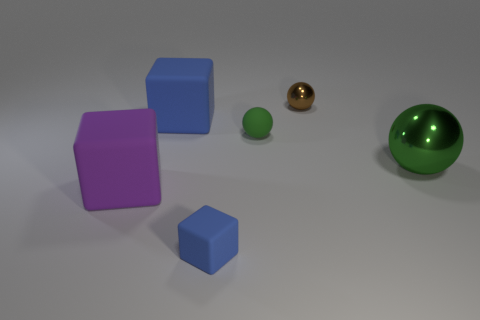What is the size of the green metal thing that is the same shape as the green rubber thing?
Your answer should be very brief. Large. What is the size of the object that is the same color as the small block?
Your answer should be compact. Large. Are there any blue rubber blocks that have the same size as the purple object?
Your answer should be compact. Yes. Does the big object that is right of the small blue matte object have the same color as the matte thing behind the tiny green matte thing?
Provide a short and direct response. No. Is there another shiny thing of the same color as the tiny shiny object?
Keep it short and to the point. No. There is a shiny object that is right of the brown metallic object; what shape is it?
Provide a short and direct response. Sphere. There is a tiny shiny object; is its shape the same as the large thing in front of the large green metal sphere?
Your answer should be compact. No. How big is the cube that is in front of the large green thing and on the right side of the big purple cube?
Make the answer very short. Small. There is a matte thing that is both in front of the small green thing and to the right of the large purple rubber object; what color is it?
Give a very brief answer. Blue. Is there anything else that is made of the same material as the purple thing?
Offer a terse response. Yes. 